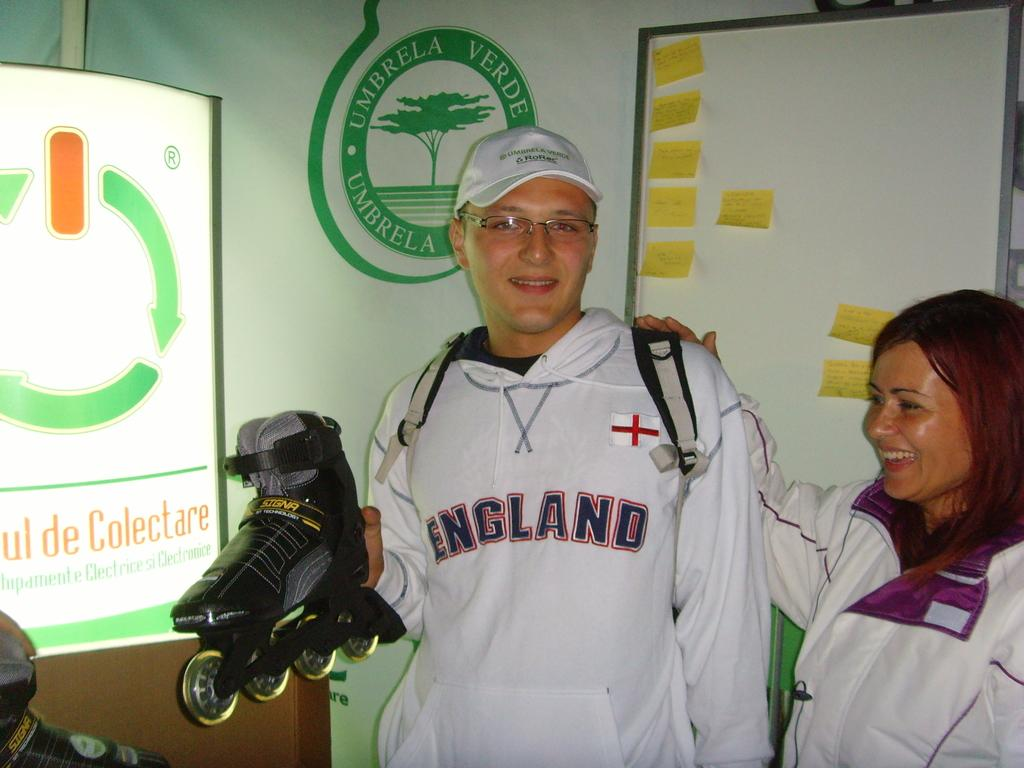<image>
Present a compact description of the photo's key features. A man wearing a sweatshirt saying England holds a roller blade in his hand. 